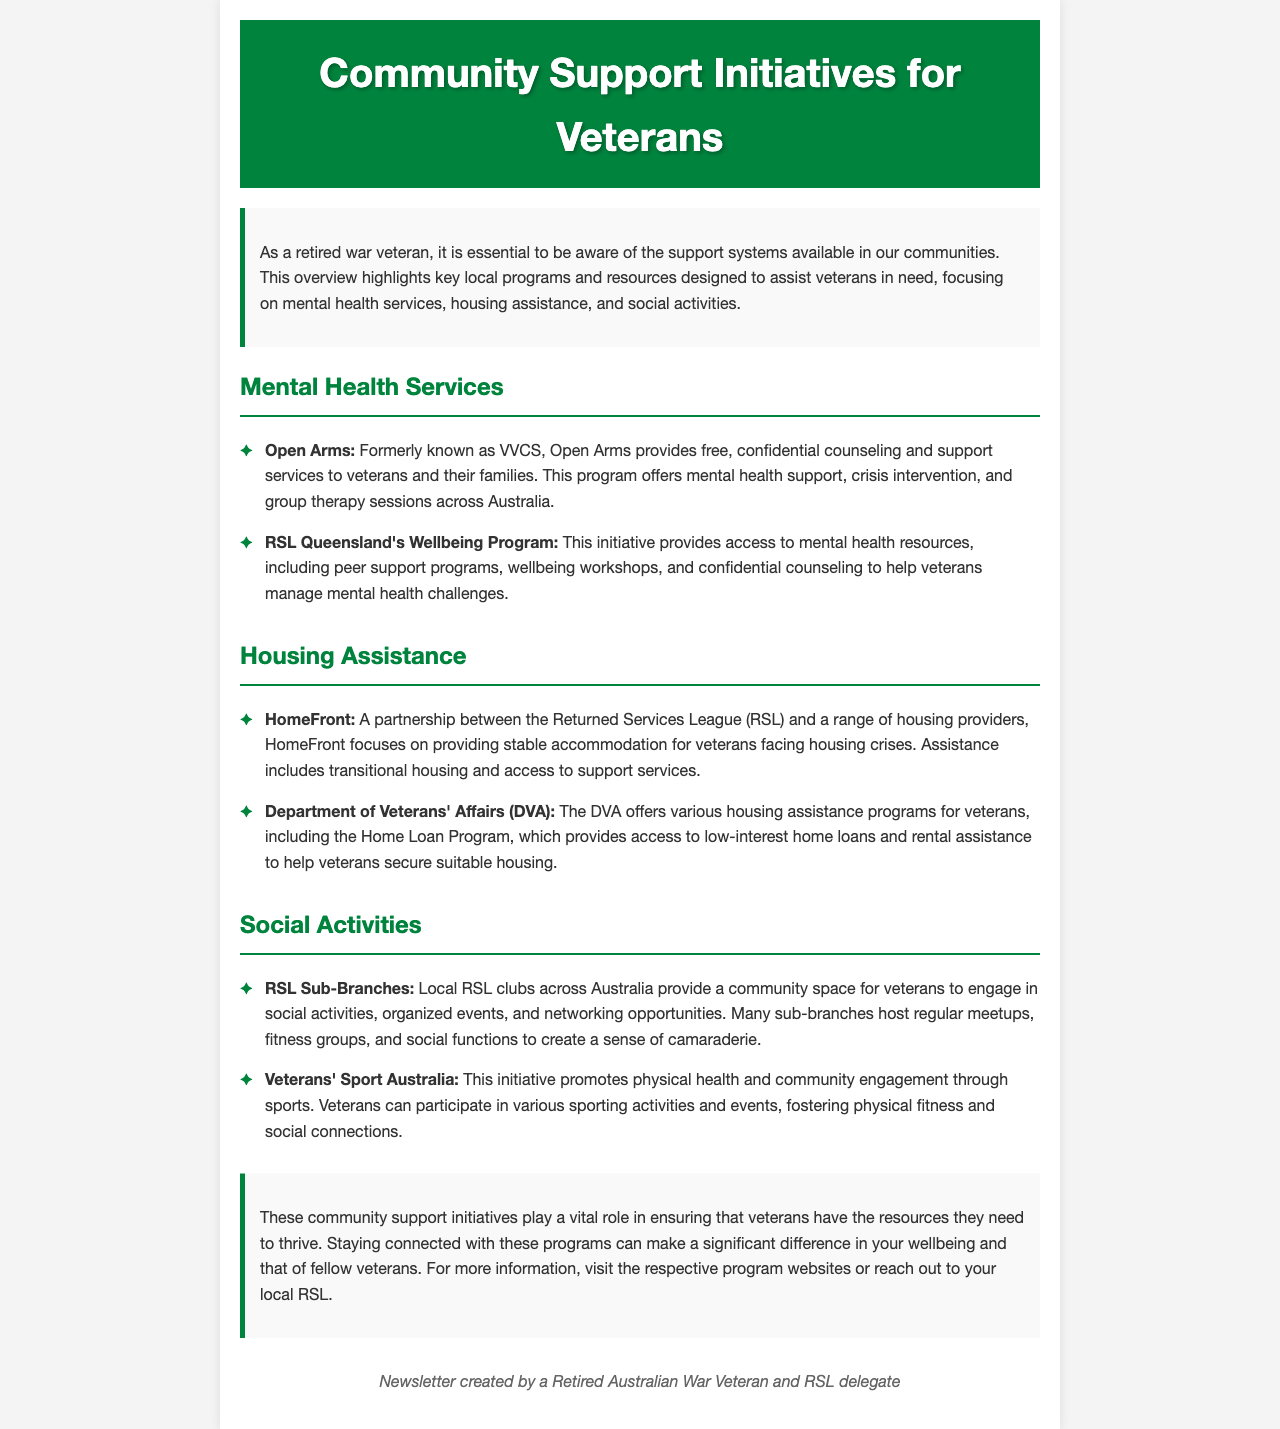What is the name of the mental health service formerly known as VVCS? The document states that "Open Arms" was formerly known as VVCS, providing support for veterans.
Answer: Open Arms Which program assists veterans with housing crises? The document mentions "HomeFront" as a partnership focused on providing stable accommodation for veterans facing housing crises.
Answer: HomeFront What does DVA stand for? DVA refers to the "Department of Veterans' Affairs," which offers housing assistance programs for veterans.
Answer: Department of Veterans' Affairs What type of programs does RSL Queensland's Wellbeing Program provide? The document lists mental health resources, peer support programs, and wellbeing workshops as part of RSL Queensland's Wellbeing Program.
Answer: Mental health resources What activities do local RSL clubs host for veterans? The document states that local RSL clubs host regular meetups, fitness groups, and social functions for veterans.
Answer: Regular meetups Which initiative promotes physical health through sports for veterans? The document mentions "Veterans' Sport Australia" as the initiative that promotes physical health and community engagement through sports.
Answer: Veterans' Sport Australia What is the purpose of the Home Loan Program provided by the DVA? The Home Loan Program aims to provide access to low-interest home loans and rental assistance for veterans.
Answer: Low-interest home loans What is the importance of the community support initiatives mentioned in the document? The document emphasizes these initiatives are vital for ensuring veterans have necessary resources to thrive.
Answer: Vital resources 